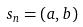<formula> <loc_0><loc_0><loc_500><loc_500>s _ { n } = ( a , b )</formula> 